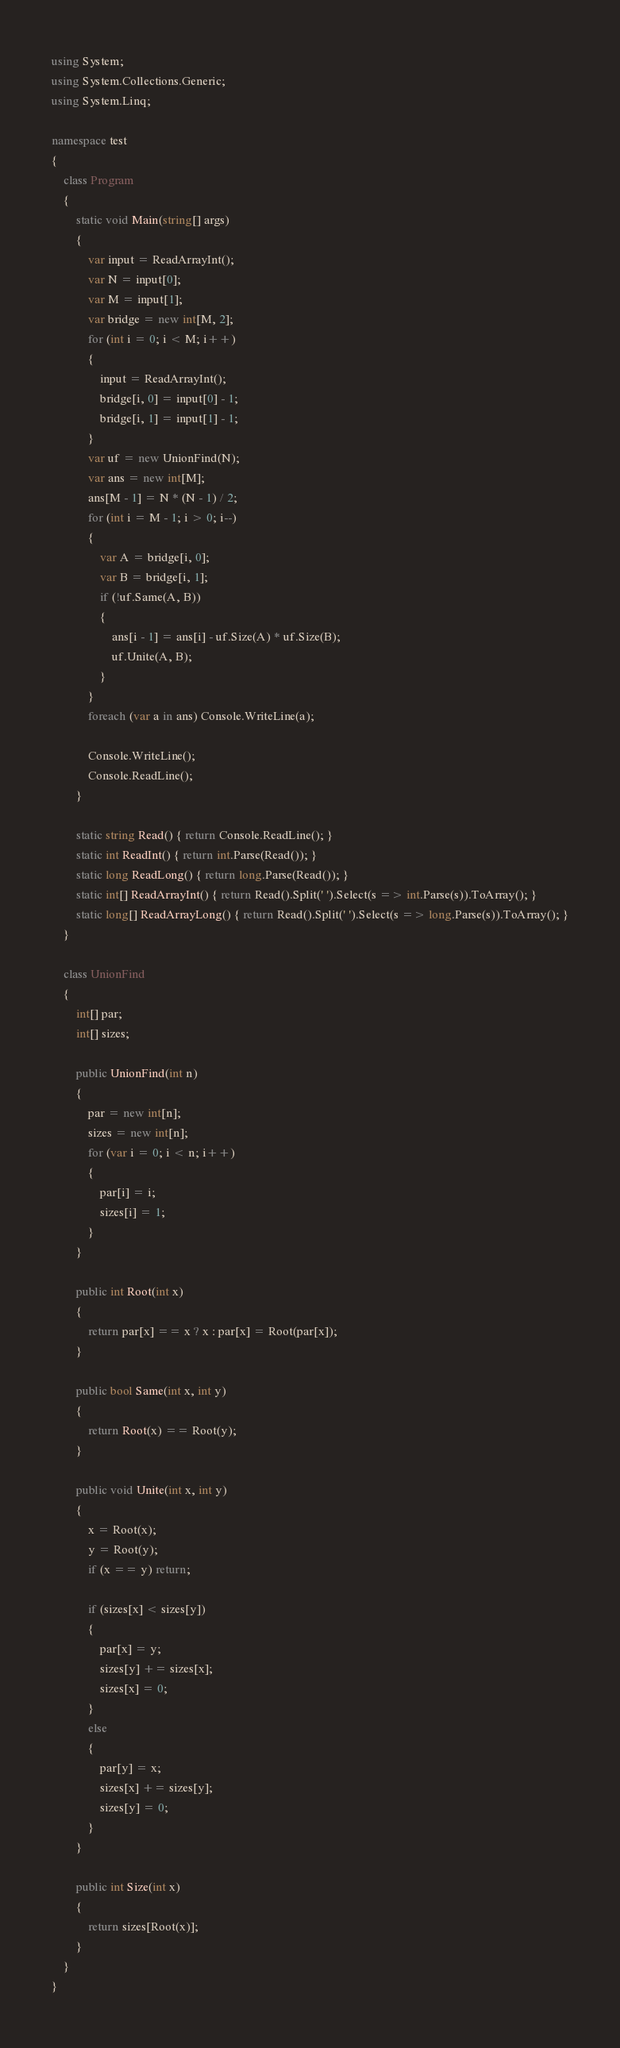<code> <loc_0><loc_0><loc_500><loc_500><_C#_>using System;
using System.Collections.Generic;
using System.Linq;

namespace test
{
    class Program
    {
        static void Main(string[] args)
        {
            var input = ReadArrayInt();
            var N = input[0];
            var M = input[1];
            var bridge = new int[M, 2];
            for (int i = 0; i < M; i++)
            {
                input = ReadArrayInt();
                bridge[i, 0] = input[0] - 1;
                bridge[i, 1] = input[1] - 1;
            }
            var uf = new UnionFind(N);
            var ans = new int[M];
            ans[M - 1] = N * (N - 1) / 2;
            for (int i = M - 1; i > 0; i--)
            {
                var A = bridge[i, 0];
                var B = bridge[i, 1];
                if (!uf.Same(A, B))
                {
                    ans[i - 1] = ans[i] - uf.Size(A) * uf.Size(B);
                    uf.Unite(A, B);
                }
            }
            foreach (var a in ans) Console.WriteLine(a);

            Console.WriteLine();
            Console.ReadLine();
        }

        static string Read() { return Console.ReadLine(); }
        static int ReadInt() { return int.Parse(Read()); }
        static long ReadLong() { return long.Parse(Read()); }
        static int[] ReadArrayInt() { return Read().Split(' ').Select(s => int.Parse(s)).ToArray(); }
        static long[] ReadArrayLong() { return Read().Split(' ').Select(s => long.Parse(s)).ToArray(); }
    }

    class UnionFind
    {
        int[] par;
        int[] sizes;

        public UnionFind(int n)
        {
            par = new int[n];
            sizes = new int[n];
            for (var i = 0; i < n; i++)
            {
                par[i] = i;
                sizes[i] = 1;
            }
        }

        public int Root(int x)
        {
            return par[x] == x ? x : par[x] = Root(par[x]);
        }

        public bool Same(int x, int y)
        {
            return Root(x) == Root(y);
        }

        public void Unite(int x, int y)
        {
            x = Root(x);
            y = Root(y);
            if (x == y) return;

            if (sizes[x] < sizes[y])
            {
                par[x] = y;
                sizes[y] += sizes[x];
                sizes[x] = 0;
            }
            else
            {
                par[y] = x;
                sizes[x] += sizes[y];
                sizes[y] = 0;
            }
        }

        public int Size(int x)
        {
            return sizes[Root(x)];
        }
    }
}</code> 